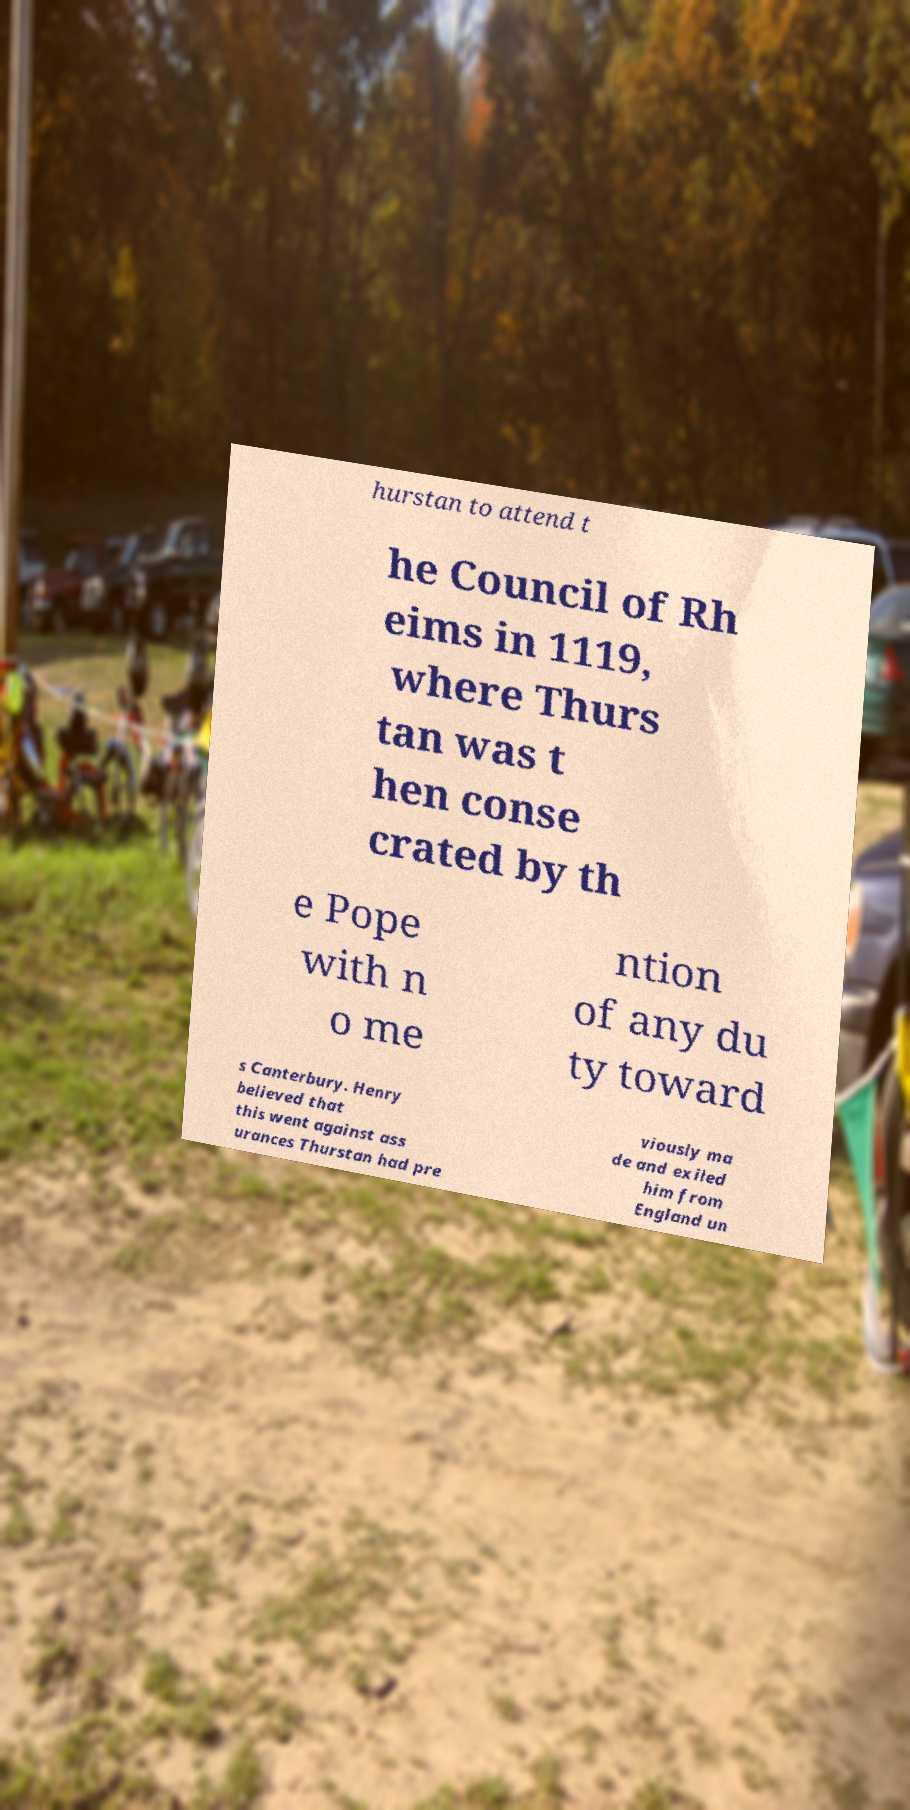Can you read and provide the text displayed in the image?This photo seems to have some interesting text. Can you extract and type it out for me? hurstan to attend t he Council of Rh eims in 1119, where Thurs tan was t hen conse crated by th e Pope with n o me ntion of any du ty toward s Canterbury. Henry believed that this went against ass urances Thurstan had pre viously ma de and exiled him from England un 